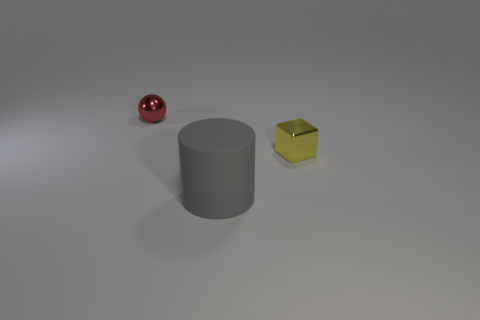Add 2 tiny shiny blocks. How many objects exist? 5 Subtract all red cubes. Subtract all blue balls. How many cubes are left? 1 Subtract all cyan balls. How many red blocks are left? 0 Subtract all metallic things. Subtract all cylinders. How many objects are left? 0 Add 1 shiny things. How many shiny things are left? 3 Add 3 shiny spheres. How many shiny spheres exist? 4 Subtract 1 gray cylinders. How many objects are left? 2 Subtract all spheres. How many objects are left? 2 